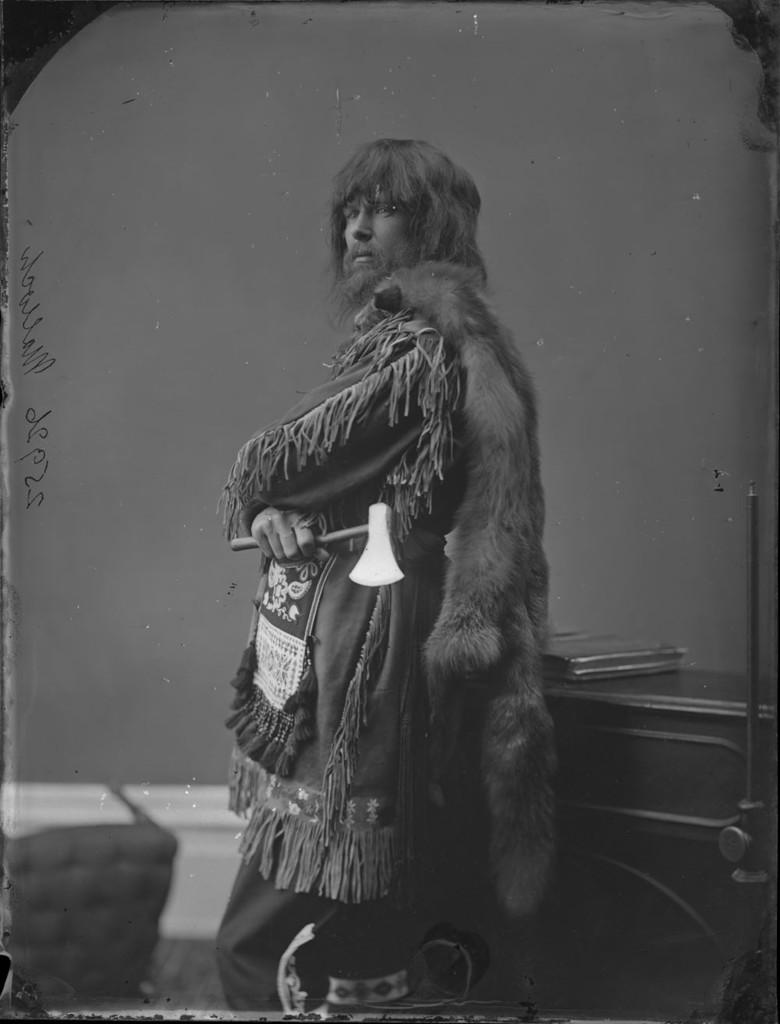Who is present in the image? There is a man in the image. What is the man doing in the image? The man is standing in front of a cabinet. What object is the man holding in the image? The man is holding an axe. What type of furniture can be seen in the image? There is a chair in the image. What is the background of the image? There is a wall in the image. What type of jail can be seen in the image? There is no jail present in the image. How many toes are visible on the man's feet in the image? The image does not show the man's feet, so it is impossible to determine the number of toes visible. 